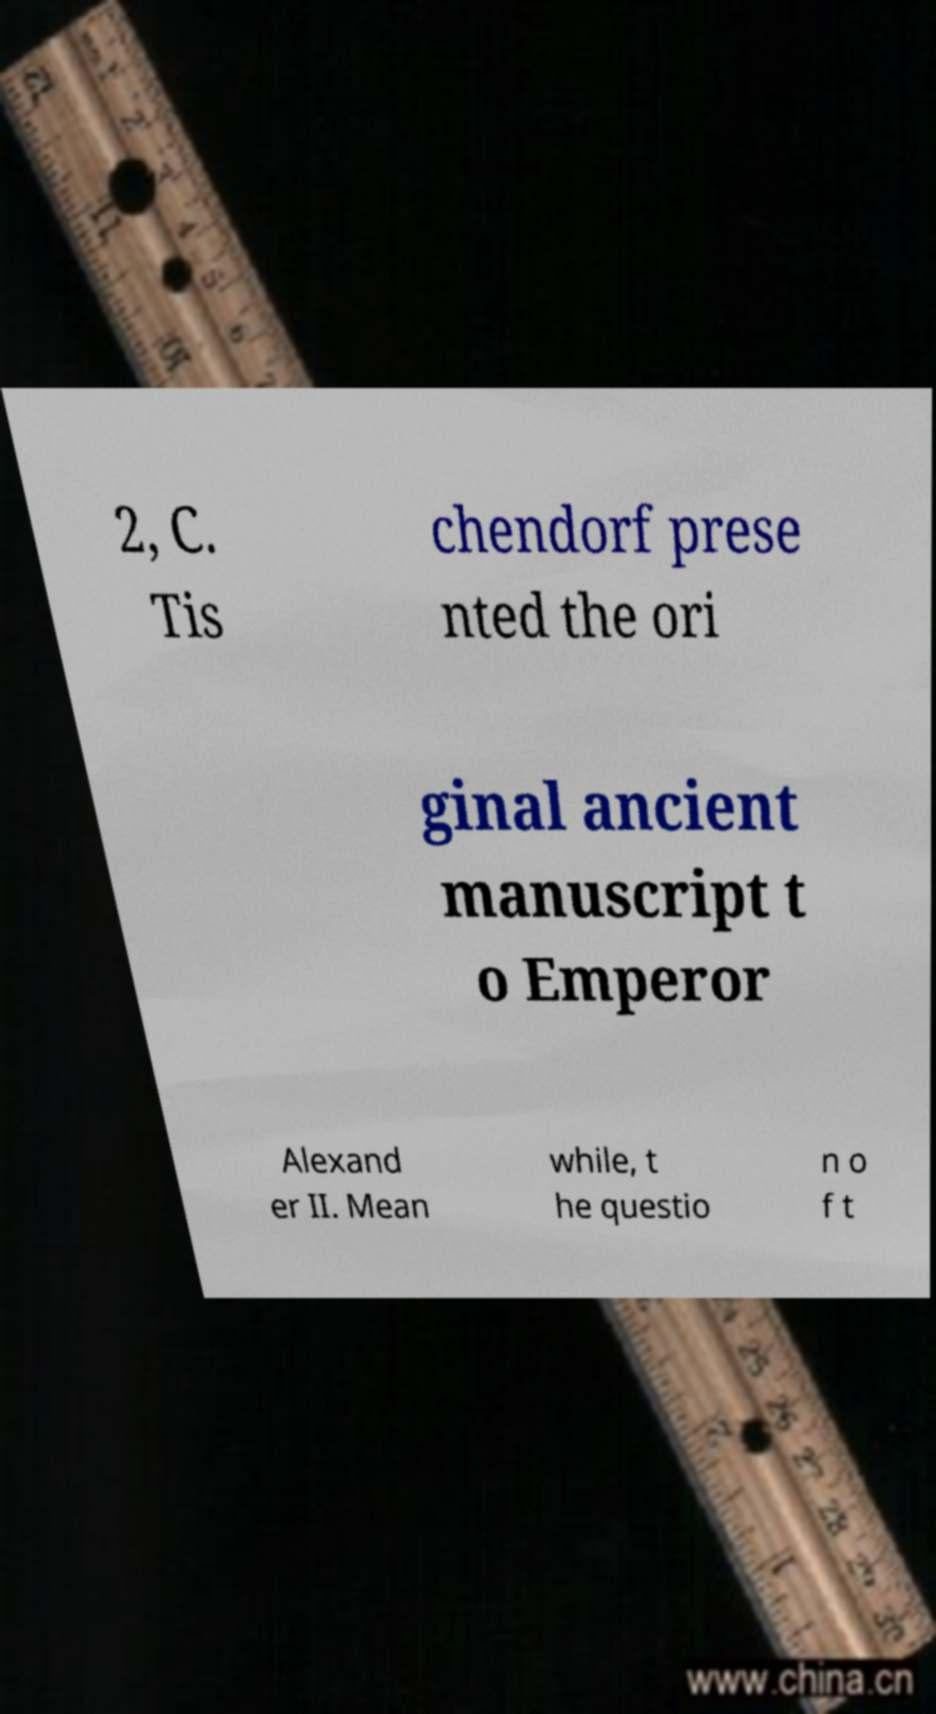Can you accurately transcribe the text from the provided image for me? 2, C. Tis chendorf prese nted the ori ginal ancient manuscript t o Emperor Alexand er II. Mean while, t he questio n o f t 